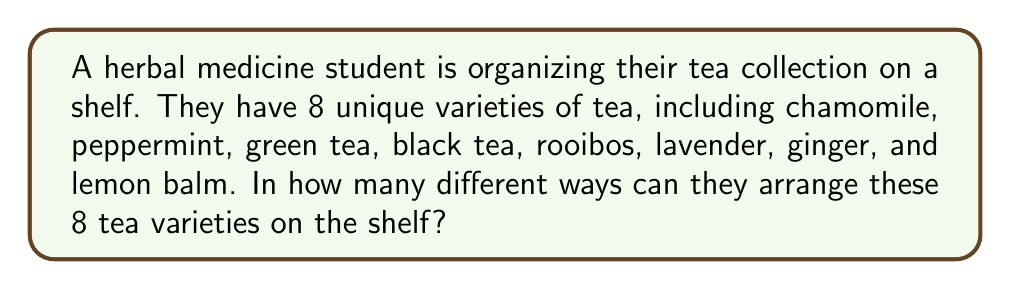Show me your answer to this math problem. To solve this problem, we need to consider the following:

1. We have 8 distinct tea varieties.
2. Each tea variety can be placed in any position on the shelf.
3. The order of arrangement matters (e.g., chamomile first, then peppermint is different from peppermint first, then chamomile).
4. All tea varieties must be used in each arrangement.

This scenario is a perfect example of a permutation problem. Specifically, it's a permutation of 8 distinct objects.

The formula for permutations of n distinct objects is:

$$ P(n) = n! $$

Where $n!$ represents the factorial of n.

In this case, $n = 8$, so we need to calculate $8!$:

$$ 8! = 8 \times 7 \times 6 \times 5 \times 4 \times 3 \times 2 \times 1 $$

Let's calculate this step by step:

$$ 8 \times 7 = 56 $$
$$ 56 \times 6 = 336 $$
$$ 336 \times 5 = 1,680 $$
$$ 1,680 \times 4 = 6,720 $$
$$ 6,720 \times 3 = 20,160 $$
$$ 20,160 \times 2 = 40,320 $$
$$ 40,320 \times 1 = 40,320 $$

Therefore, the number of ways to arrange 8 unique tea varieties on a shelf is 40,320.
Answer: 40,320 